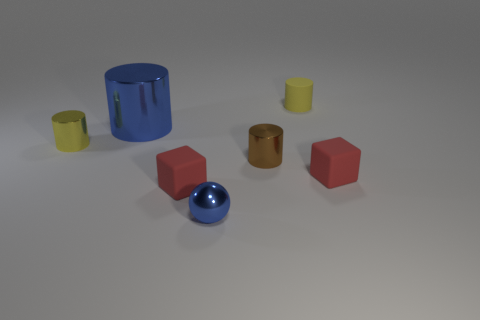Subtract all tiny matte cylinders. How many cylinders are left? 3 Subtract 2 cylinders. How many cylinders are left? 2 Subtract all green cylinders. Subtract all green blocks. How many cylinders are left? 4 Add 3 big gray matte blocks. How many objects exist? 10 Subtract all cubes. How many objects are left? 5 Subtract all tiny yellow matte objects. Subtract all brown metallic objects. How many objects are left? 5 Add 4 big cylinders. How many big cylinders are left? 5 Add 6 brown metallic cylinders. How many brown metallic cylinders exist? 7 Subtract 0 yellow spheres. How many objects are left? 7 